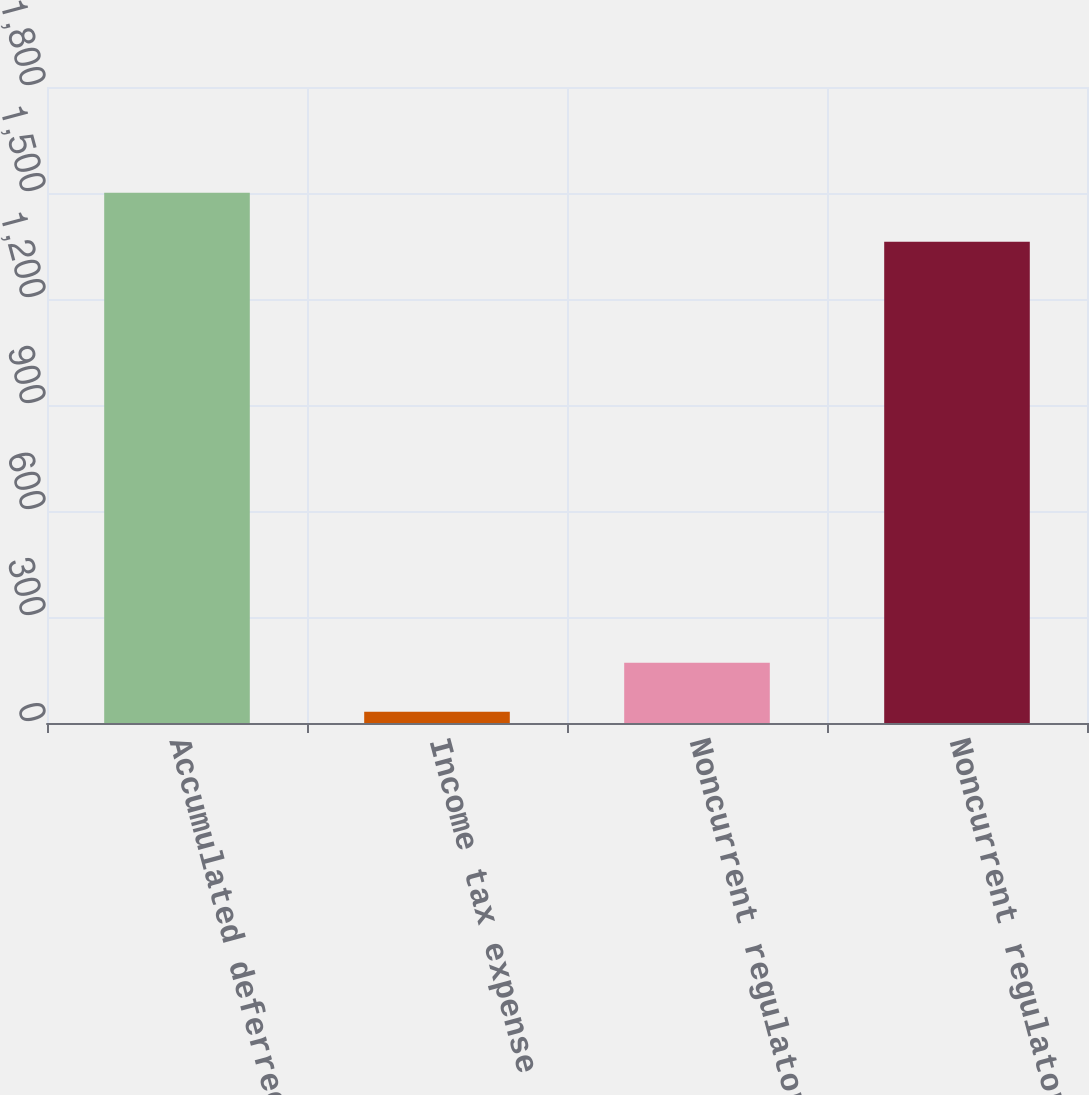<chart> <loc_0><loc_0><loc_500><loc_500><bar_chart><fcel>Accumulated deferred income<fcel>Income tax expense (benefit)<fcel>Noncurrent regulatory assets<fcel>Noncurrent regulatory<nl><fcel>1500.7<fcel>32<fcel>170.7<fcel>1362<nl></chart> 